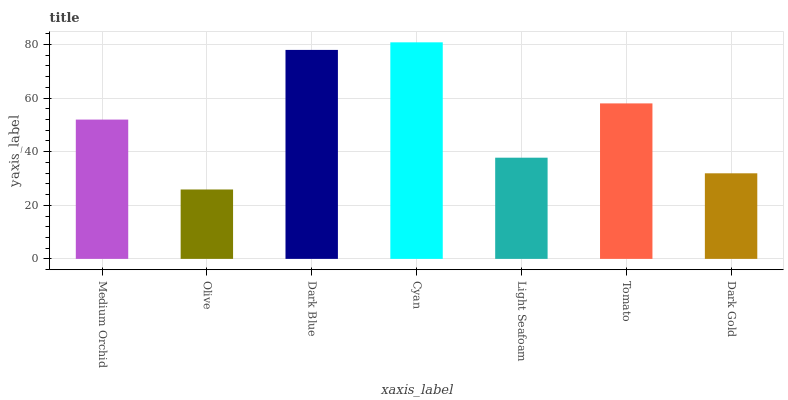Is Dark Blue the minimum?
Answer yes or no. No. Is Dark Blue the maximum?
Answer yes or no. No. Is Dark Blue greater than Olive?
Answer yes or no. Yes. Is Olive less than Dark Blue?
Answer yes or no. Yes. Is Olive greater than Dark Blue?
Answer yes or no. No. Is Dark Blue less than Olive?
Answer yes or no. No. Is Medium Orchid the high median?
Answer yes or no. Yes. Is Medium Orchid the low median?
Answer yes or no. Yes. Is Light Seafoam the high median?
Answer yes or no. No. Is Olive the low median?
Answer yes or no. No. 